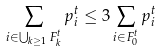Convert formula to latex. <formula><loc_0><loc_0><loc_500><loc_500>\sum _ { i \in \bigcup _ { k \geq 1 } F _ { k } ^ { t } } p _ { i } ^ { t } \leq 3 \sum _ { i \in F _ { 0 } ^ { t } } p _ { i } ^ { t }</formula> 